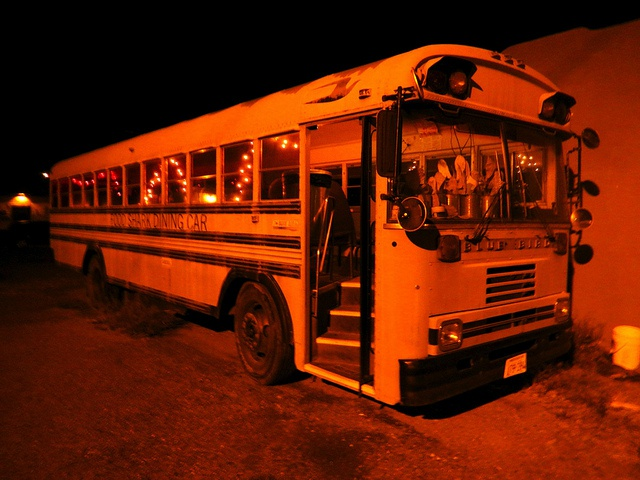Describe the objects in this image and their specific colors. I can see bus in black, red, maroon, and brown tones in this image. 